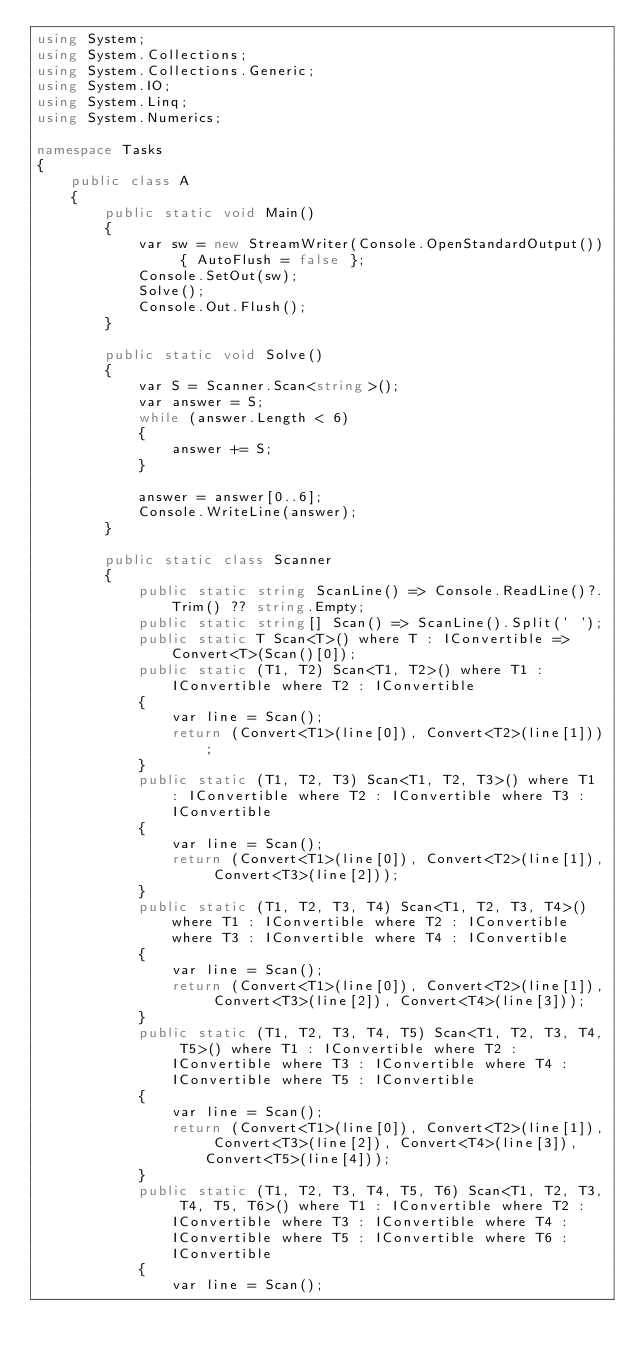<code> <loc_0><loc_0><loc_500><loc_500><_C#_>using System;
using System.Collections;
using System.Collections.Generic;
using System.IO;
using System.Linq;
using System.Numerics;

namespace Tasks
{
    public class A
    {
        public static void Main()
        {
            var sw = new StreamWriter(Console.OpenStandardOutput()) { AutoFlush = false };
            Console.SetOut(sw);
            Solve();
            Console.Out.Flush();
        }

        public static void Solve()
        {
            var S = Scanner.Scan<string>();
            var answer = S;
            while (answer.Length < 6)
            {
                answer += S;
            }

            answer = answer[0..6];
            Console.WriteLine(answer);
        }

        public static class Scanner
        {
            public static string ScanLine() => Console.ReadLine()?.Trim() ?? string.Empty;
            public static string[] Scan() => ScanLine().Split(' ');
            public static T Scan<T>() where T : IConvertible => Convert<T>(Scan()[0]);
            public static (T1, T2) Scan<T1, T2>() where T1 : IConvertible where T2 : IConvertible
            {
                var line = Scan();
                return (Convert<T1>(line[0]), Convert<T2>(line[1]));
            }
            public static (T1, T2, T3) Scan<T1, T2, T3>() where T1 : IConvertible where T2 : IConvertible where T3 : IConvertible
            {
                var line = Scan();
                return (Convert<T1>(line[0]), Convert<T2>(line[1]), Convert<T3>(line[2]));
            }
            public static (T1, T2, T3, T4) Scan<T1, T2, T3, T4>() where T1 : IConvertible where T2 : IConvertible where T3 : IConvertible where T4 : IConvertible
            {
                var line = Scan();
                return (Convert<T1>(line[0]), Convert<T2>(line[1]), Convert<T3>(line[2]), Convert<T4>(line[3]));
            }
            public static (T1, T2, T3, T4, T5) Scan<T1, T2, T3, T4, T5>() where T1 : IConvertible where T2 : IConvertible where T3 : IConvertible where T4 : IConvertible where T5 : IConvertible
            {
                var line = Scan();
                return (Convert<T1>(line[0]), Convert<T2>(line[1]), Convert<T3>(line[2]), Convert<T4>(line[3]), Convert<T5>(line[4]));
            }
            public static (T1, T2, T3, T4, T5, T6) Scan<T1, T2, T3, T4, T5, T6>() where T1 : IConvertible where T2 : IConvertible where T3 : IConvertible where T4 : IConvertible where T5 : IConvertible where T6 : IConvertible
            {
                var line = Scan();</code> 